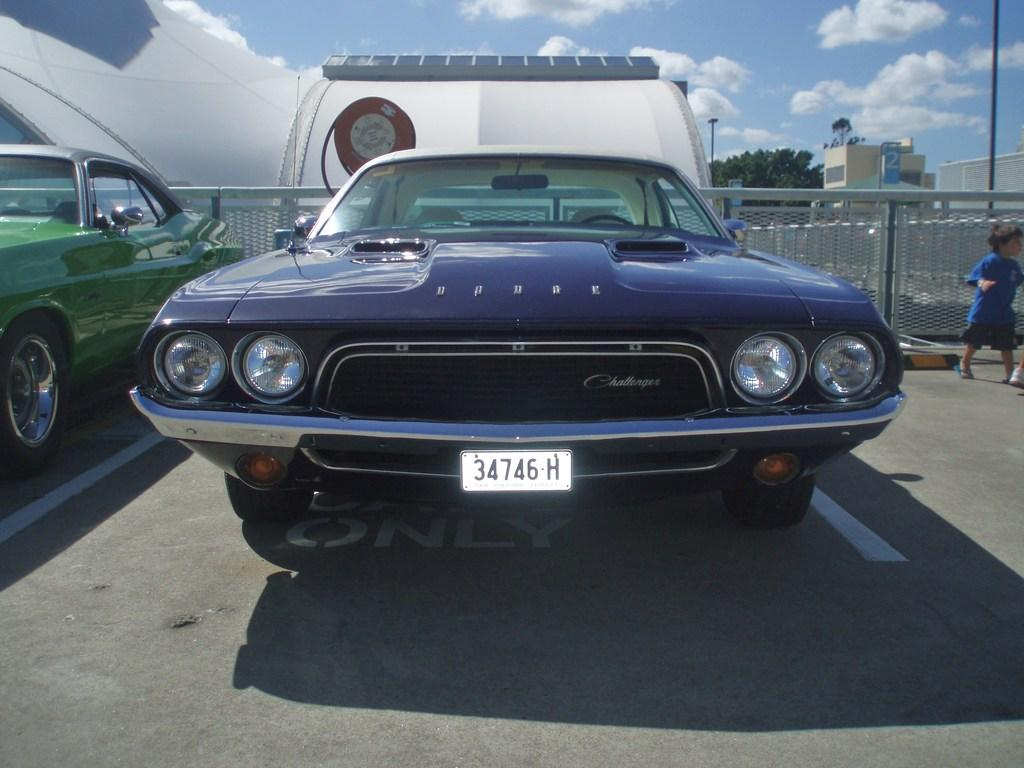What type of vehicles can be seen in the image? There are cars in the image. What is the child doing in the image? A child is walking on the road in the image. What type of barrier is present in the image? There is a fence in the image. What type of vegetation is present in the image? Trees are present in the image. What type of vertical structures can be seen in the image? Poles are visible in the image. What is visible in the background of the image? The sky with clouds is visible in the background of the image. What type of beast is causing destruction in the bedroom in the image? There is no beast or bedroom present in the image. 